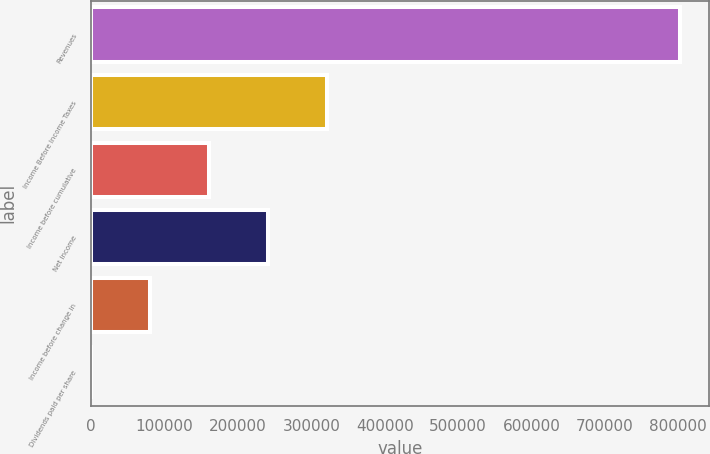<chart> <loc_0><loc_0><loc_500><loc_500><bar_chart><fcel>Revenues<fcel>Income Before Income Taxes<fcel>Income before cumulative<fcel>Net Income<fcel>Income before change in<fcel>Dividends paid per share<nl><fcel>802417<fcel>320967<fcel>160484<fcel>240725<fcel>80241.8<fcel>0.13<nl></chart> 